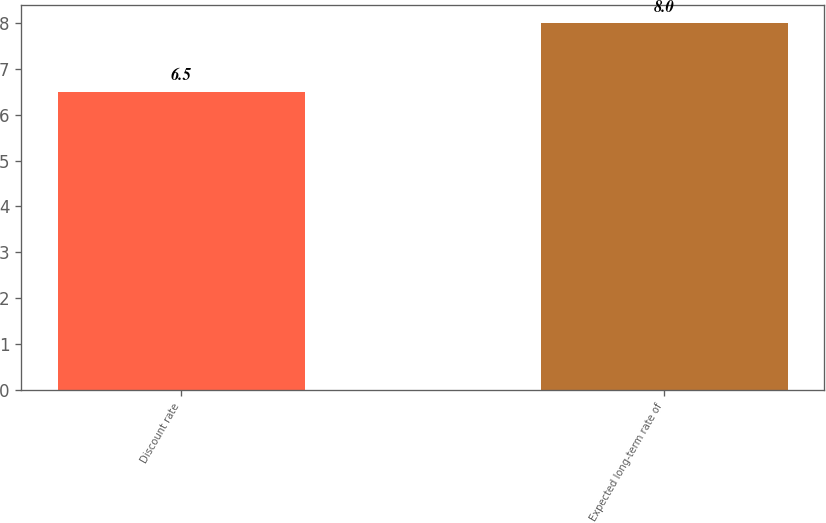Convert chart. <chart><loc_0><loc_0><loc_500><loc_500><bar_chart><fcel>Discount rate<fcel>Expected long-term rate of<nl><fcel>6.5<fcel>8<nl></chart> 